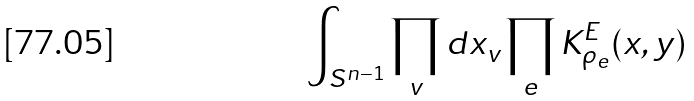<formula> <loc_0><loc_0><loc_500><loc_500>\int _ { S ^ { n - 1 } } \prod _ { v } d x _ { v } \prod _ { e } K _ { \rho _ { e } } ^ { E } ( x , y )</formula> 